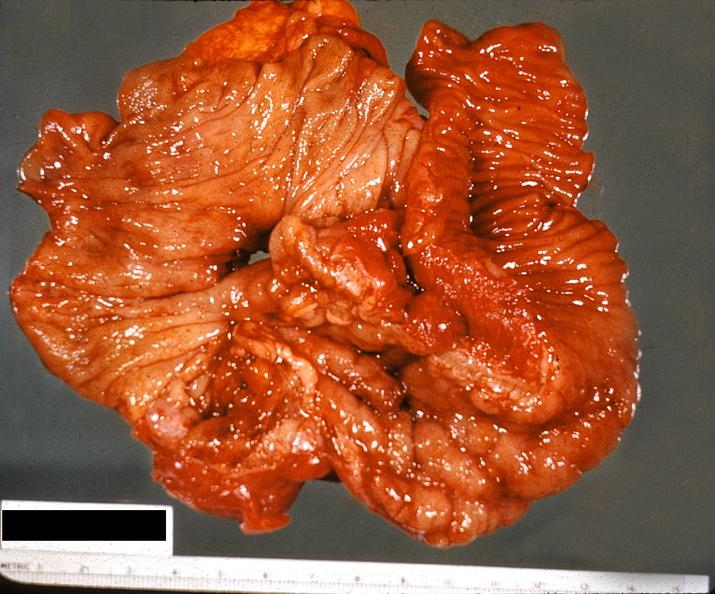does this image show ileum, regional enteritis?
Answer the question using a single word or phrase. Yes 